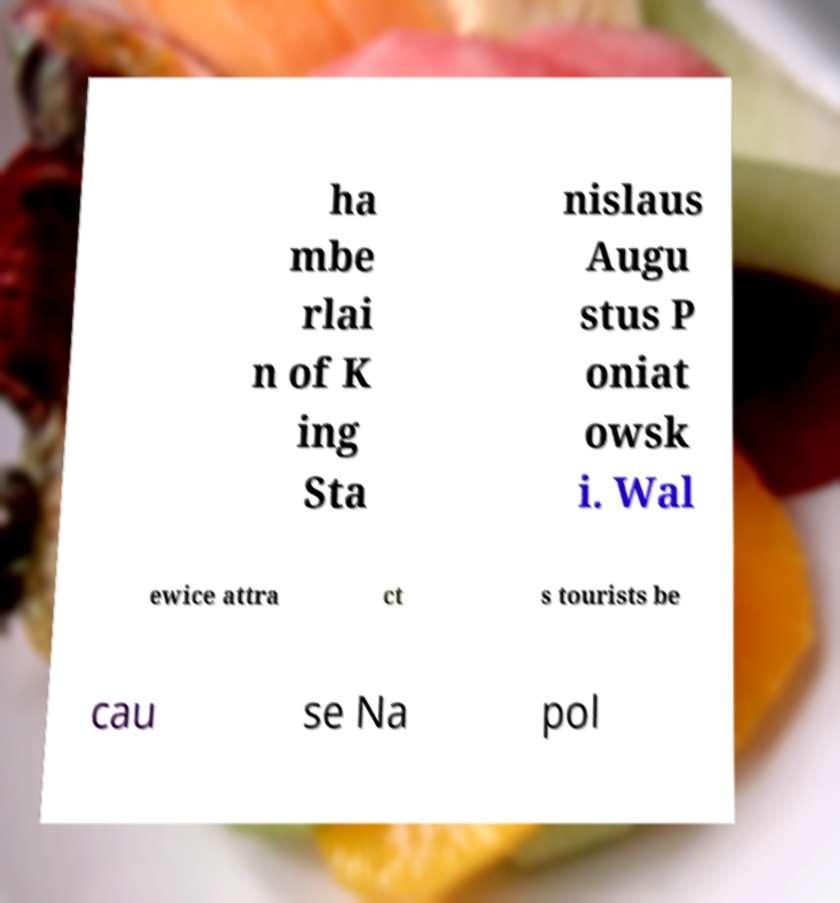For documentation purposes, I need the text within this image transcribed. Could you provide that? ha mbe rlai n of K ing Sta nislaus Augu stus P oniat owsk i. Wal ewice attra ct s tourists be cau se Na pol 